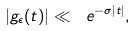Convert formula to latex. <formula><loc_0><loc_0><loc_500><loc_500>| g _ { \epsilon } ( t ) | \ll \ e ^ { - \sigma | t | } ,</formula> 